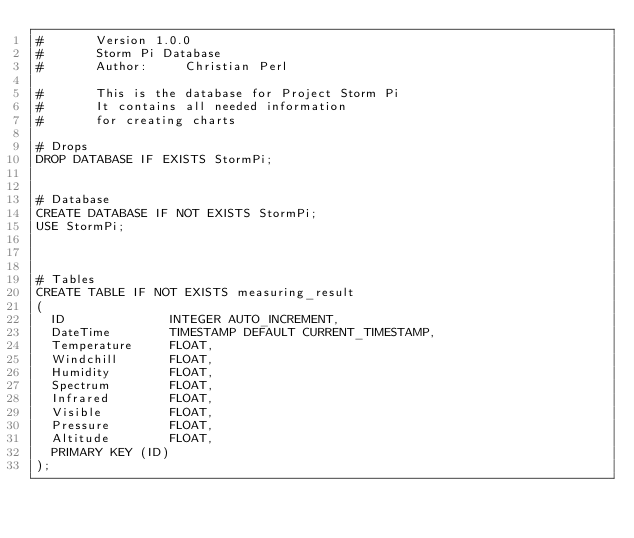Convert code to text. <code><loc_0><loc_0><loc_500><loc_500><_SQL_>#       Version 1.0.0
#       Storm Pi Database
#       Author:     Christian Perl

#       This is the database for Project Storm Pi
#       It contains all needed information
#       for creating charts

# Drops
DROP DATABASE IF EXISTS StormPi;


# Database
CREATE DATABASE IF NOT EXISTS StormPi;
USE StormPi;



# Tables
CREATE TABLE IF NOT EXISTS measuring_result
(
  ID              INTEGER AUTO_INCREMENT,
  DateTime        TIMESTAMP DEFAULT CURRENT_TIMESTAMP,
  Temperature     FLOAT,
  Windchill       FLOAT,
  Humidity        FLOAT,
  Spectrum        FLOAT,
  Infrared        FLOAT,
  Visible         FLOAT,
  Pressure        FLOAT,
  Altitude        FLOAT,
  PRIMARY KEY (ID)
);

</code> 